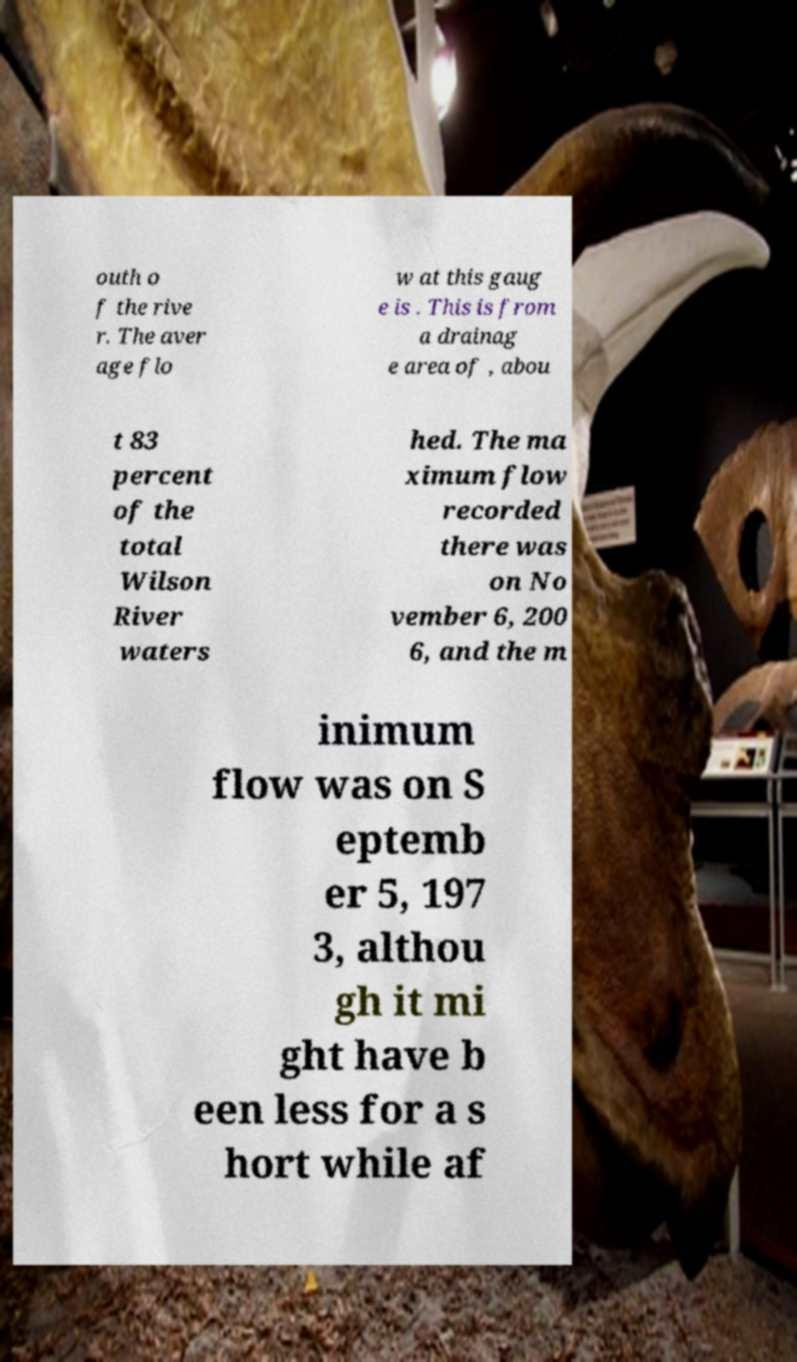Could you assist in decoding the text presented in this image and type it out clearly? outh o f the rive r. The aver age flo w at this gaug e is . This is from a drainag e area of , abou t 83 percent of the total Wilson River waters hed. The ma ximum flow recorded there was on No vember 6, 200 6, and the m inimum flow was on S eptemb er 5, 197 3, althou gh it mi ght have b een less for a s hort while af 